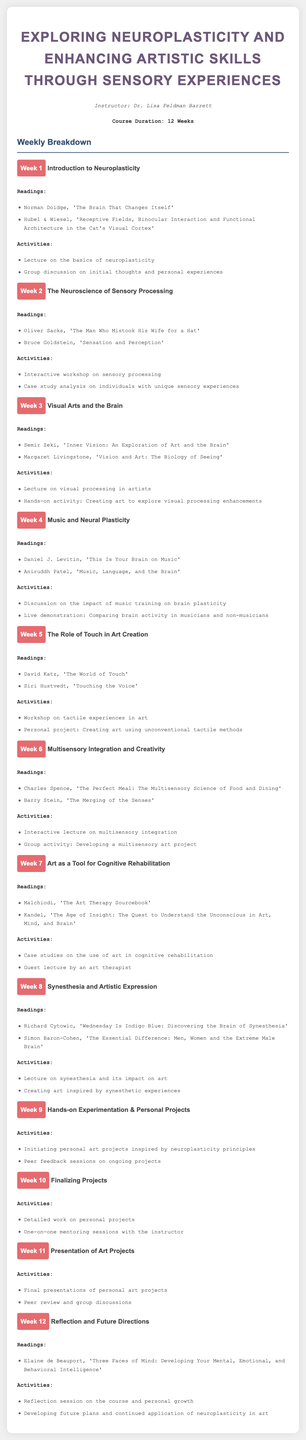What is the title of the course? The title is stated at the beginning of the document, which is "Exploring Neuroplasticity and Enhancing Artistic Skills through Sensory Experiences".
Answer: Exploring Neuroplasticity and Enhancing Artistic Skills through Sensory Experiences Who is the instructor of the course? The instructor's name is mentioned in the document, specifically as "Dr. Lisa Feldman Barrett".
Answer: Dr. Lisa Feldman Barrett How many weeks is the course? The total duration of the course is specified in the document as "12 Weeks".
Answer: 12 Weeks What is the main focus of Week 3? The main focus area for Week 3 is indicated in its title, "Visual Arts and the Brain".
Answer: Visual Arts and the Brain Which reading is assigned for Week 8? The document lists specific readings for each week, one of which is "Wednesday Is Indigo Blue: Discovering the Brain of Synesthesia" for Week 8.
Answer: Wednesday Is Indigo Blue: Discovering the Brain of Synesthesia What activity is scheduled for Week 6? An activity for Week 6 includes "Group activity: Developing a multisensory art project", which is part of the week’s content.
Answer: Group activity: Developing a multisensory art project How many readings are listed for Week 4? The number of readings for Week 4 is stated in its section, which shows a total of "2" readings.
Answer: 2 What is a major theme discussed in Week 7? The title of Week 7 indicates the theme, which is "Art as a Tool for Cognitive Rehabilitation".
Answer: Art as a Tool for Cognitive Rehabilitation What type of session is held in Week 12? The document specifies a reflection session under activities for Week 12, thus indicating a reflective type of session.
Answer: Reflection session 